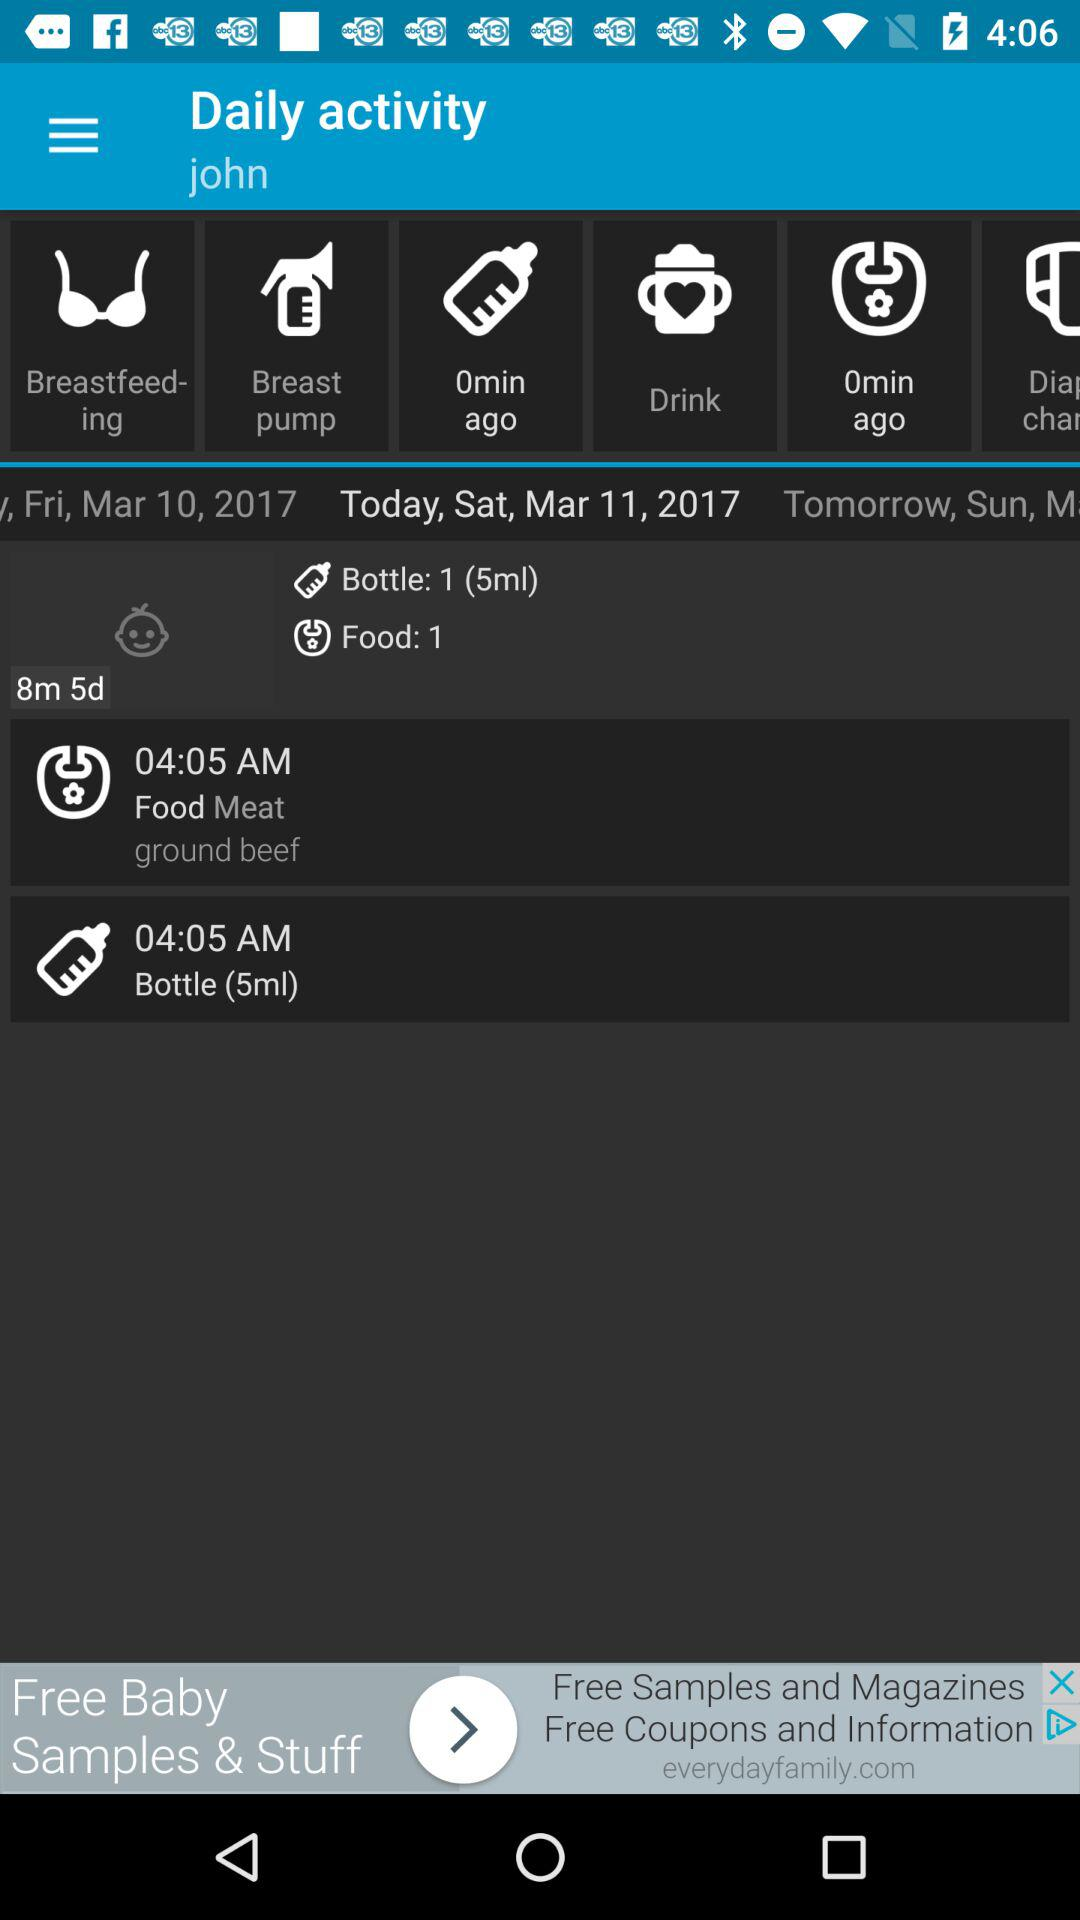What is the time? The time is 04:05 AM. 